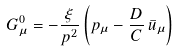<formula> <loc_0><loc_0><loc_500><loc_500>G _ { \mu } ^ { 0 } = - { \frac { \xi } { p ^ { 2 } } } \left ( p _ { \mu } - { \frac { D } { C } } \, \bar { u } _ { \mu } \right )</formula> 